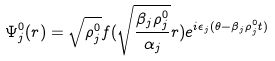Convert formula to latex. <formula><loc_0><loc_0><loc_500><loc_500>\Psi _ { j } ^ { 0 } ( { r } ) = \sqrt { \rho _ { j } ^ { 0 } } f ( \sqrt { \frac { \beta _ { j } \rho _ { j } ^ { 0 } } { \alpha _ { j } } } r ) e ^ { i \epsilon _ { j } ( \theta - \beta _ { j } \rho _ { j } ^ { 0 } t ) }</formula> 